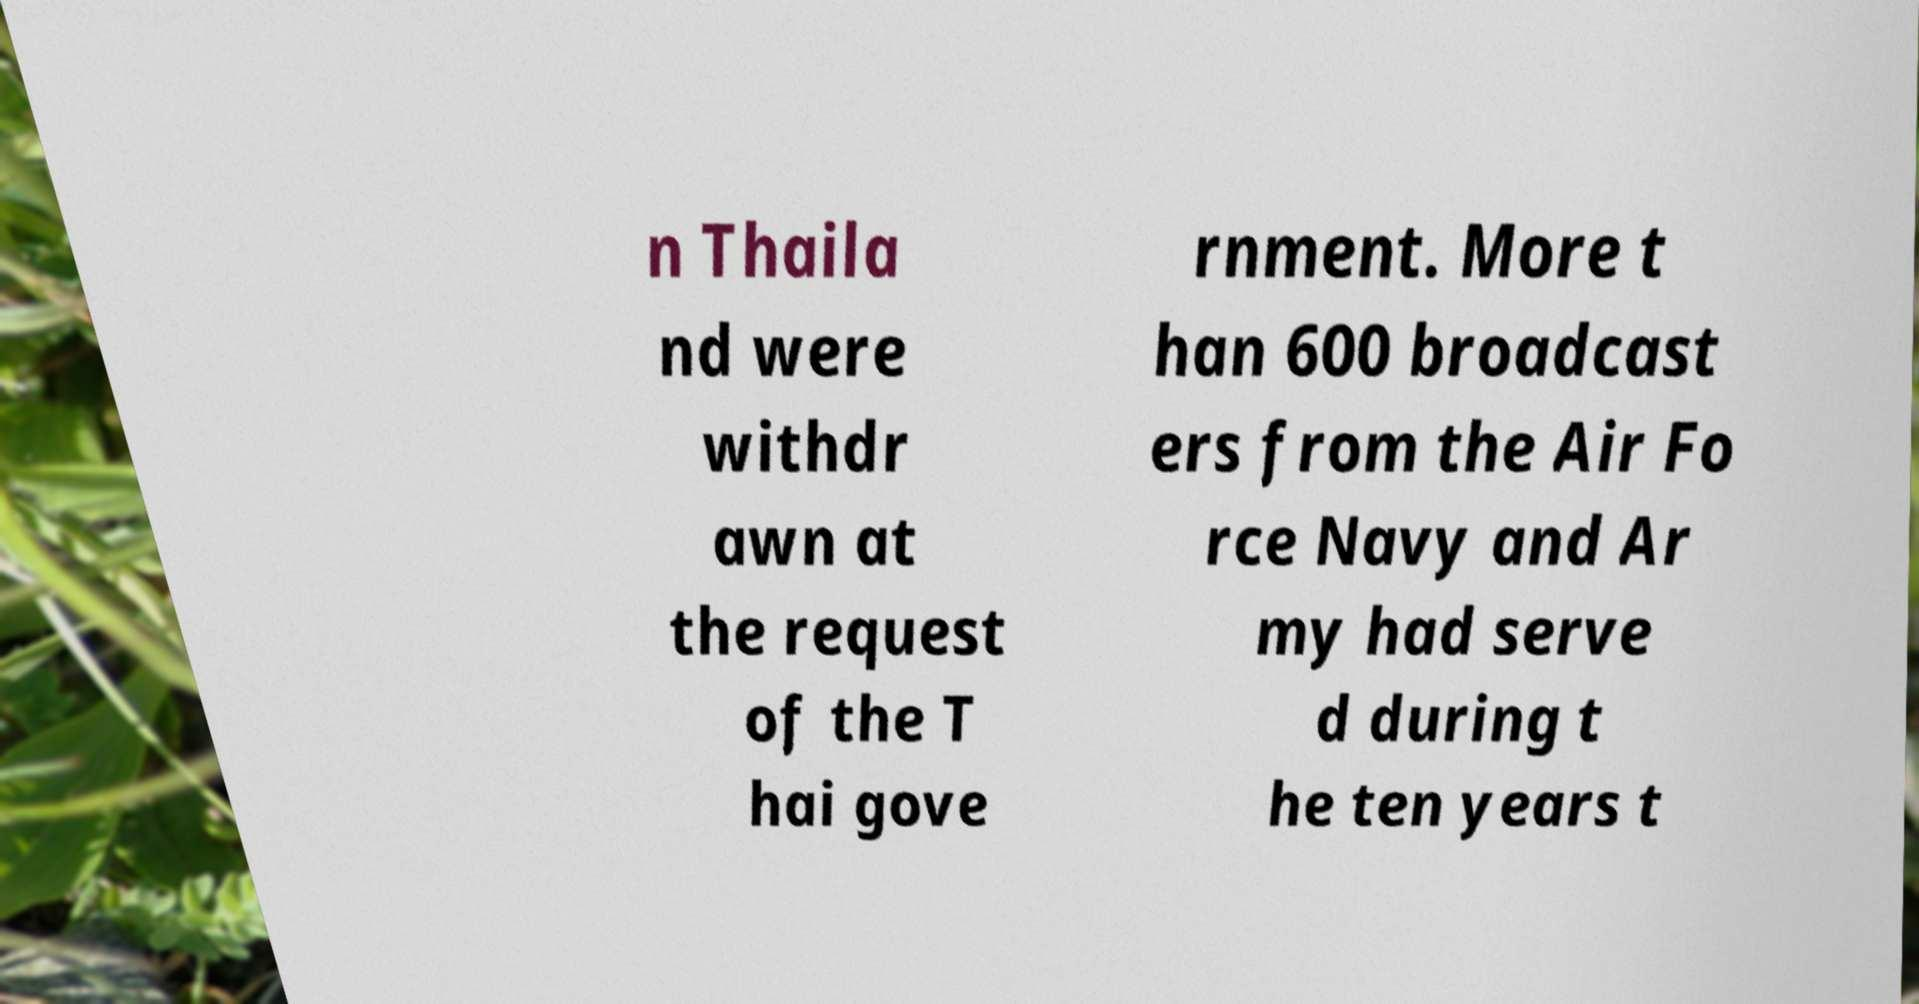Please identify and transcribe the text found in this image. n Thaila nd were withdr awn at the request of the T hai gove rnment. More t han 600 broadcast ers from the Air Fo rce Navy and Ar my had serve d during t he ten years t 